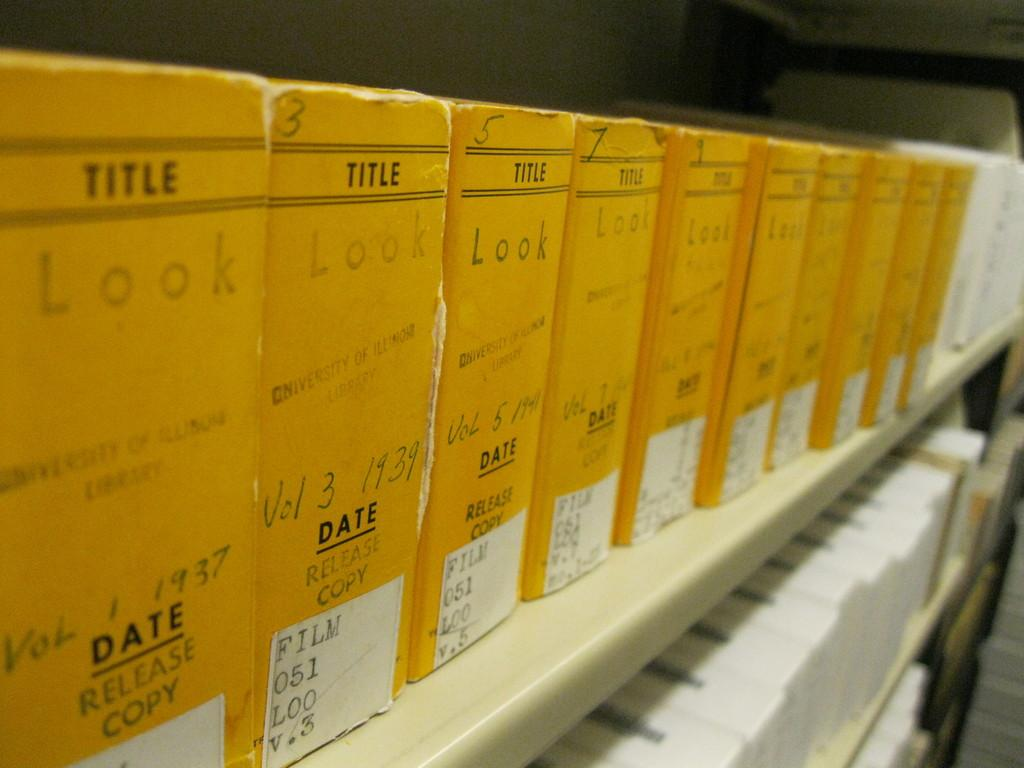<image>
Relay a brief, clear account of the picture shown. A collection of the book called Look that ranges in different volumes. 